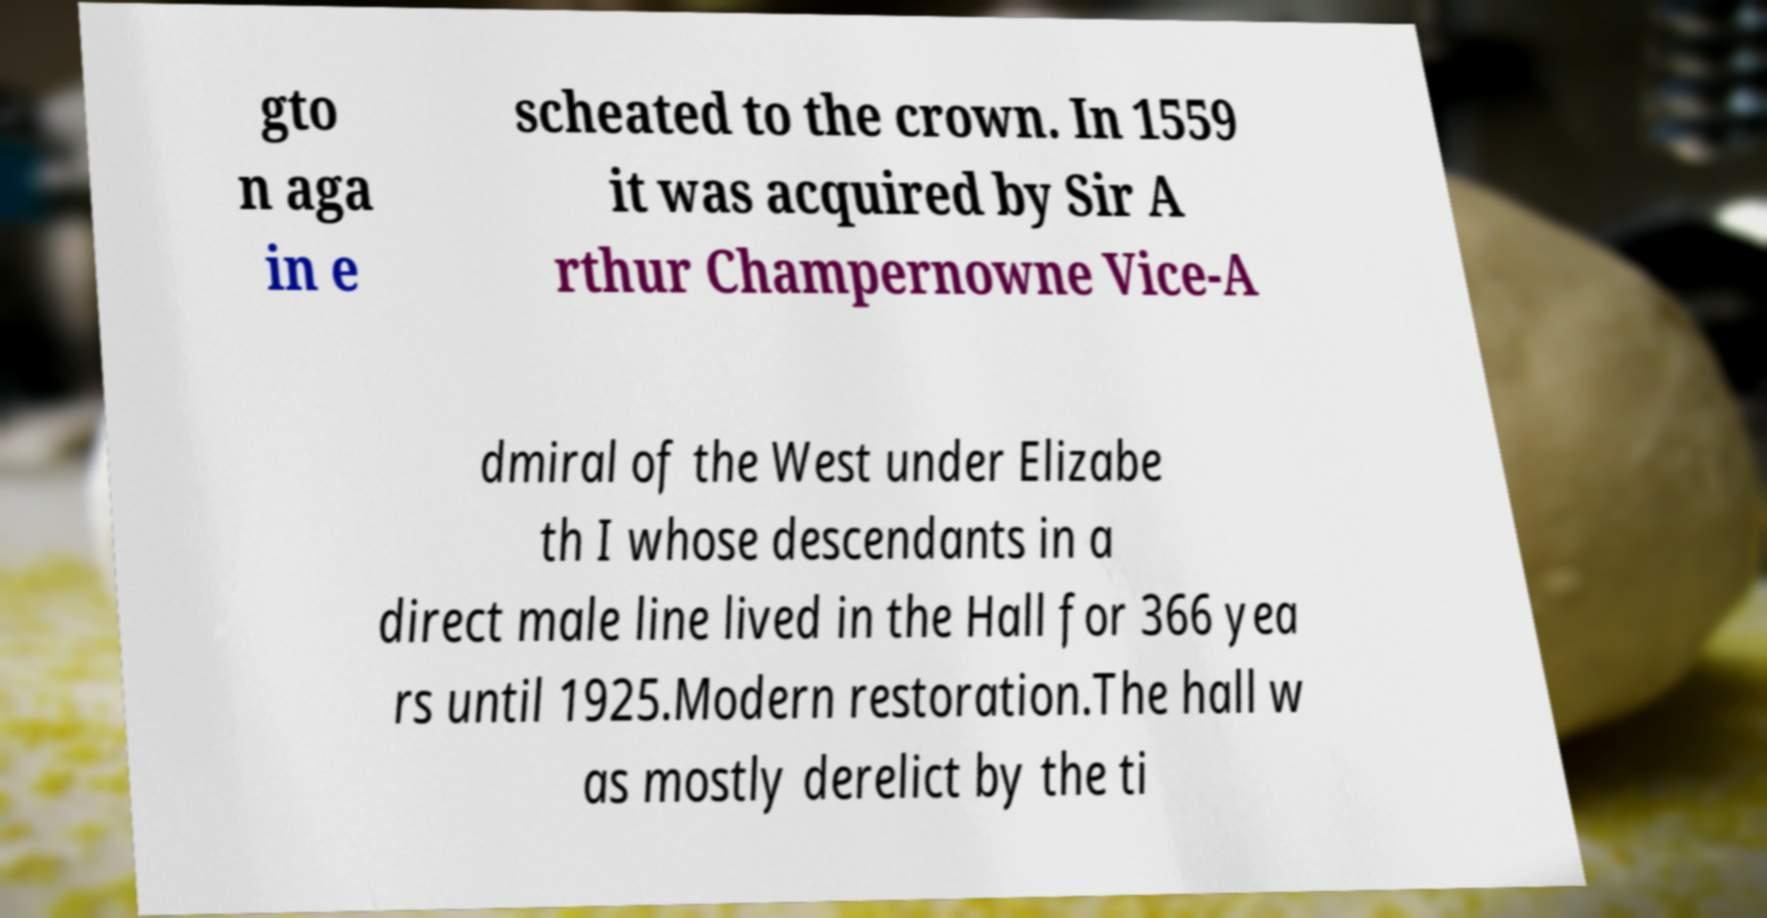There's text embedded in this image that I need extracted. Can you transcribe it verbatim? gto n aga in e scheated to the crown. In 1559 it was acquired by Sir A rthur Champernowne Vice-A dmiral of the West under Elizabe th I whose descendants in a direct male line lived in the Hall for 366 yea rs until 1925.Modern restoration.The hall w as mostly derelict by the ti 